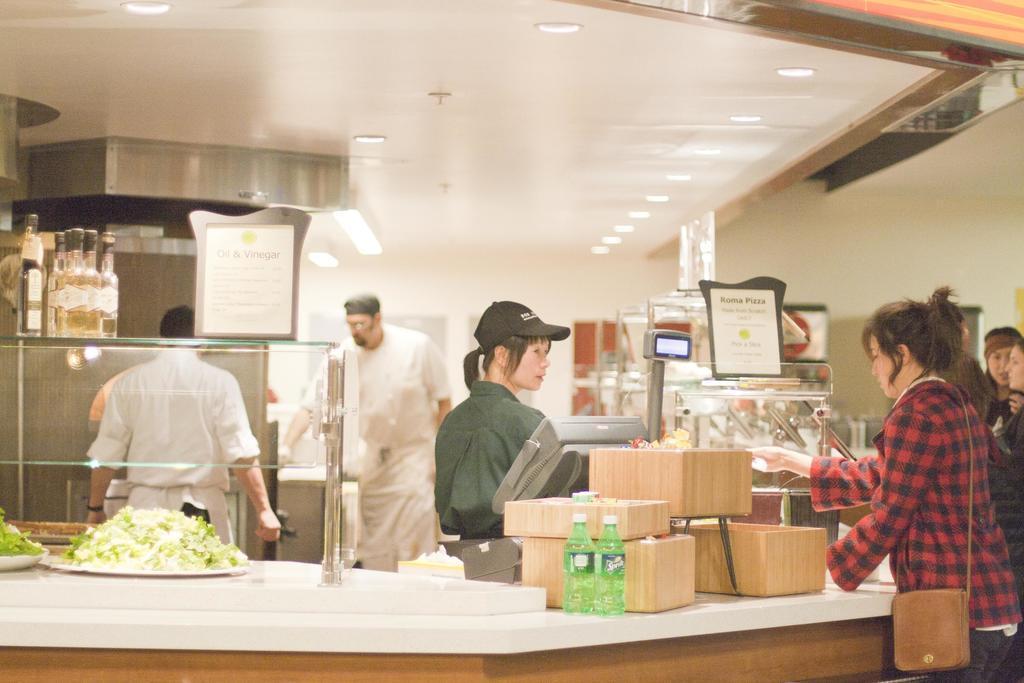Please provide a concise description of this image. To the bottom of the image there is a table. To the left side of the image on the table there is a plate with food item on it. And also there is a pole with glass. On the glass there are few bottles and also there is a poster. To the right side on the table there are brown boxes and in front of the boxes there is a monitor. In front of the monitor there is a lady with shirt and cap on her head is standing. To the right corner of the image there is a lady with red and blue checks shirt is standing. And behind her there are few people standing. And in the background there are two men with dress. To the top of the image there is a white roof with lights. 